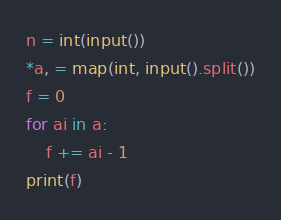Convert code to text. <code><loc_0><loc_0><loc_500><loc_500><_Python_>n = int(input())
*a, = map(int, input().split())
f = 0
for ai in a:
    f += ai - 1
print(f)</code> 